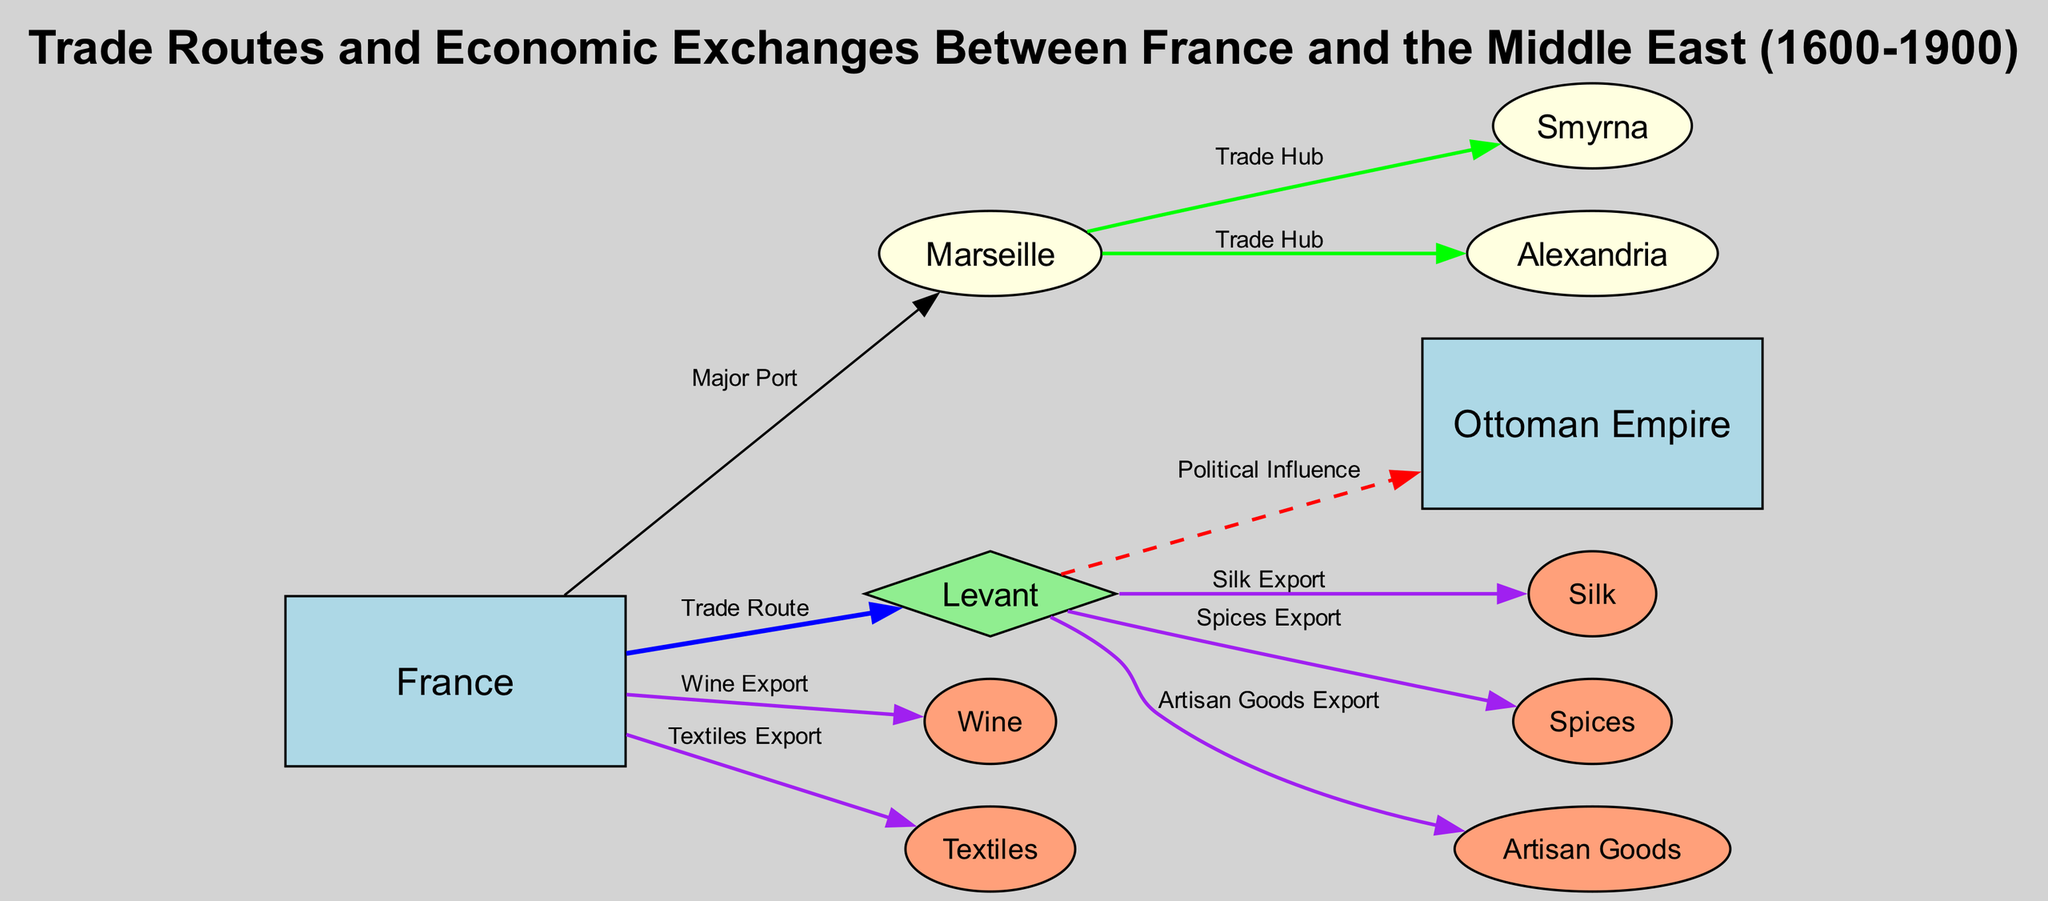What is the main trade route from France? The diagram indicates that the main trade route from France is directed towards the Levant. This can be identified by following the edge labeled "Trade Route," which connects France directly to the Levant node.
Answer: Levant Which city serves as a major port in France? According to the diagram, Marseille is highlighted as a major port in France. This is indicated by the edge from France to Marseille labeled "Major Port."
Answer: Marseille What goods are exported from the Levant? The diagram shows multiple exports from the Levant: Silk, Spices, and Artisan Goods. This information can be gathered from the edges that link the Levant to each of these goods, labeled "Silk Export," "Spices Export," and "Artisan Goods Export."
Answer: Silk, Spices, Artisan Goods How many key cities are mentioned in the trade diagram? By examining the nodes in the diagram, there are four key cities mentioned: Marseille, Smyrna, Alexandria, and the Levant itself. This is determined by counting the relevant city nodes in the diagram.
Answer: Four What political influence is represented between the Levant and the Ottoman Empire? The diagram indicates a direct political influence from the Levant to the Ottoman Empire, represented by an edge labeled "Political Influence." This shows the connection and the type of relationship between these two nodes.
Answer: Political Influence Which goods does France export to the Middle East? The diagram shows that France exports Textiles and Wine to the Middle East. This is represented by the edges from France to the respective goods, labeled "Textiles Export" and "Wine Export."
Answer: Textiles, Wine What type of relationship exists between Marseille and Smyrna? The diagram illustrates a "Trade Hub" relationship between Marseille and Smyrna. This can be seen through the edge connecting these two nodes, specifically labeled "Trade Hub."
Answer: Trade Hub How does the diagram categorize the Levant? The Levant is categorized as a diamond shape in the diagram. This shape designation indicates its significance in the trade flow and connections represented within the diagram.
Answer: Diamond What describe the main maritime and overland trade routes shown? The diagram's title and description reference the main maritime and overland trade routes between France and the Middle East, specifically highlighting maritime connections from Marseille to Smyrna and Alexandria.
Answer: Maritime and overland trade routes 